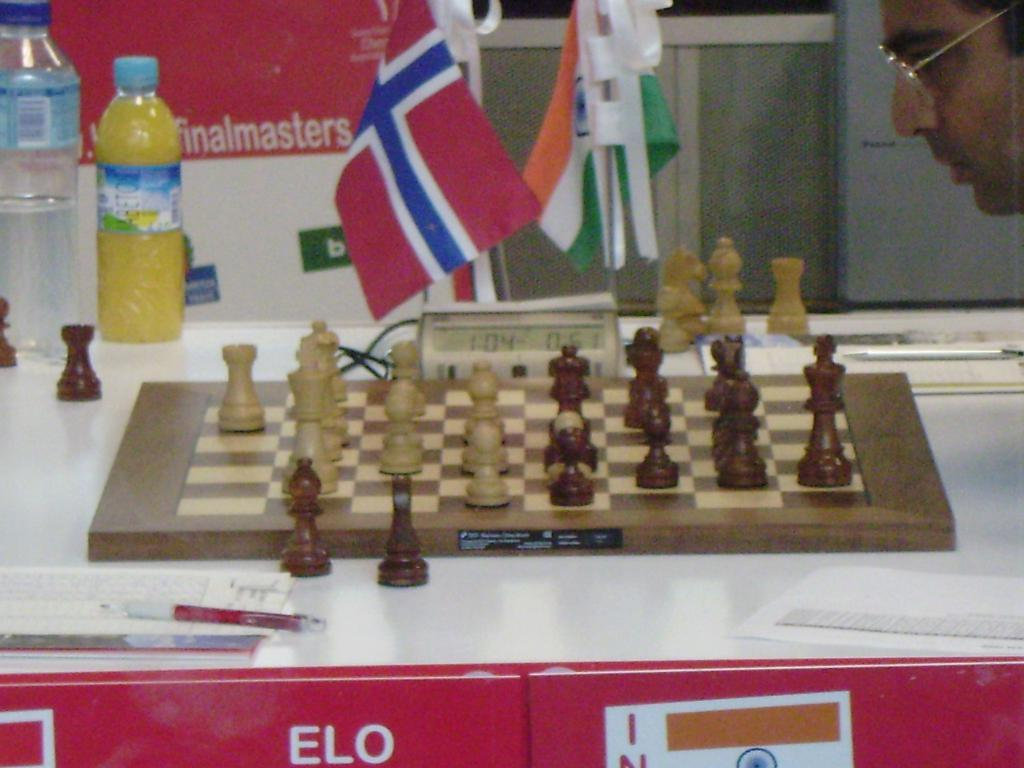What game is being played on the chess board in the image? The image does not show the chess pieces in a specific arrangement, so it cannot be determined which game is being played. What object is used to measure time in the image? There is a timer in the image. What type of container is visible in the image? There is a bottle in the image. What reading material is present in the image? There is a book in the image. What writing instrument is visible in the image? There is a pen in the image. Where are all these objects located in the image? All these objects are on a table in the image. What can be seen in the background of the image? There are flags and a wall in the background of the image. Can you describe the person in the image? There is a person wearing spectacles in the image. What type of fear can be seen on the person's face in the image? There is no indication of fear on the person's face in the image. What type of friction is present between the chess pieces in the image? The image does not show the chess pieces in a specific arrangement, so it cannot be determined if there is any friction between them. What type of seat is the person using in the image? The image does not show the person sitting or using any seat. 